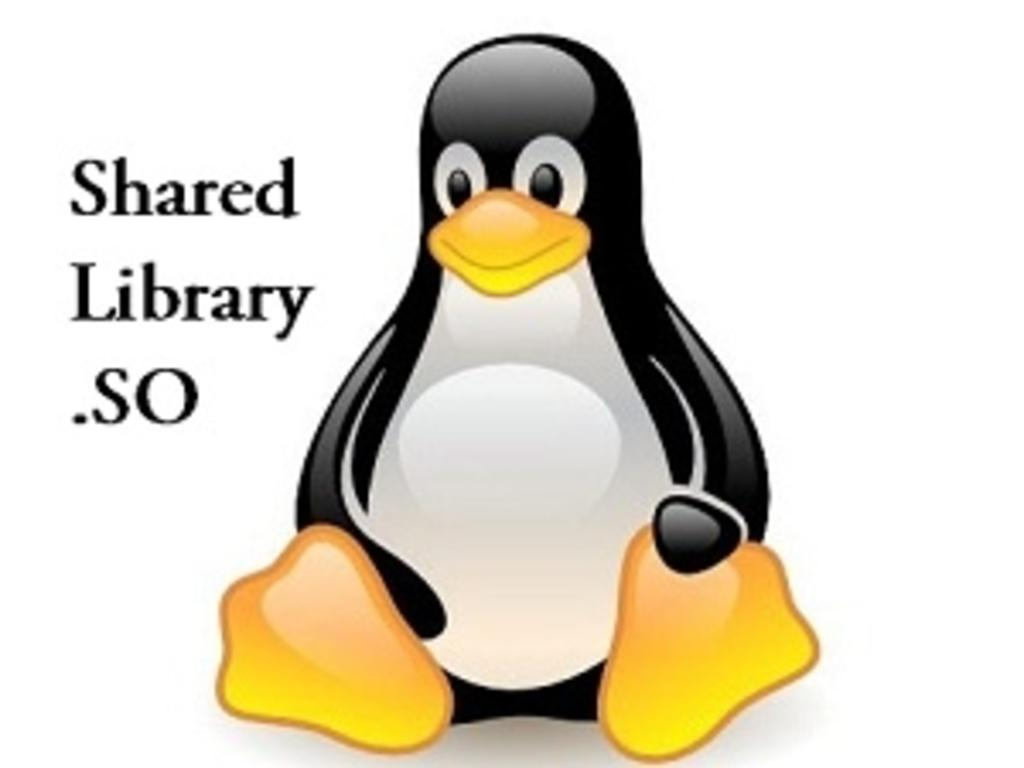What type of animal is depicted in the image? There is an animated penguin in the image. Are there any words or phrases in the image? Yes, there is some text in the image. What type of receipt can be seen in the image? There is no receipt present in the image; it features an animated penguin and some text. What material is the brass used for in the image? There is no brass present in the image. 